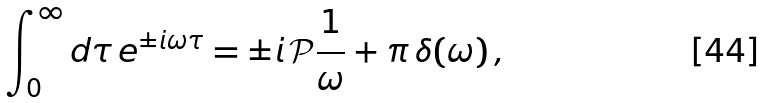Convert formula to latex. <formula><loc_0><loc_0><loc_500><loc_500>\int _ { 0 } ^ { \infty } d \tau \, e ^ { \pm i \omega \tau } = \pm i \, \mathcal { P } \frac { 1 } { \omega } + \pi \, \delta ( \omega ) \, ,</formula> 